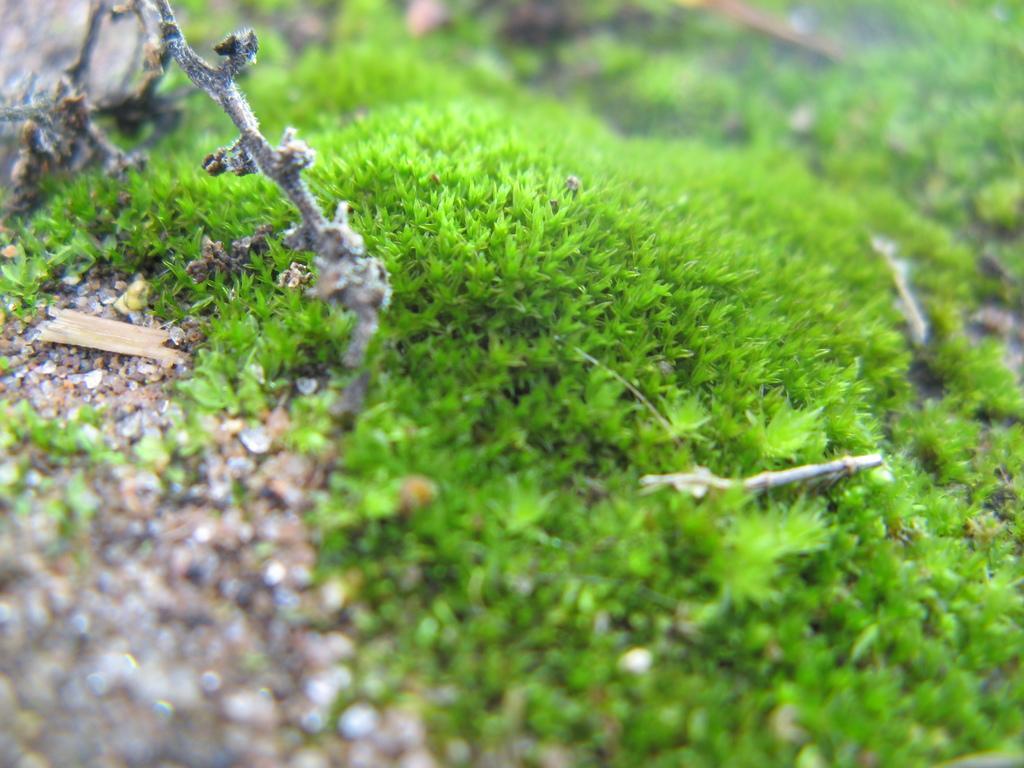Describe this image in one or two sentences. In this picture I can see grass and looks like a rock on the top right corner of the picture and I can see blurry background. 